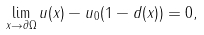<formula> <loc_0><loc_0><loc_500><loc_500>\lim _ { x \to \partial \Omega } u ( x ) - u _ { 0 } ( 1 - d ( x ) ) = 0 ,</formula> 